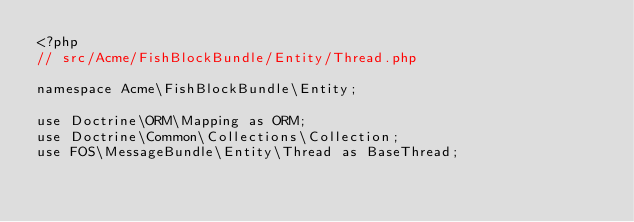Convert code to text. <code><loc_0><loc_0><loc_500><loc_500><_PHP_><?php
// src/Acme/FishBlockBundle/Entity/Thread.php

namespace Acme\FishBlockBundle\Entity;

use Doctrine\ORM\Mapping as ORM;
use Doctrine\Common\Collections\Collection;
use FOS\MessageBundle\Entity\Thread as BaseThread;</code> 